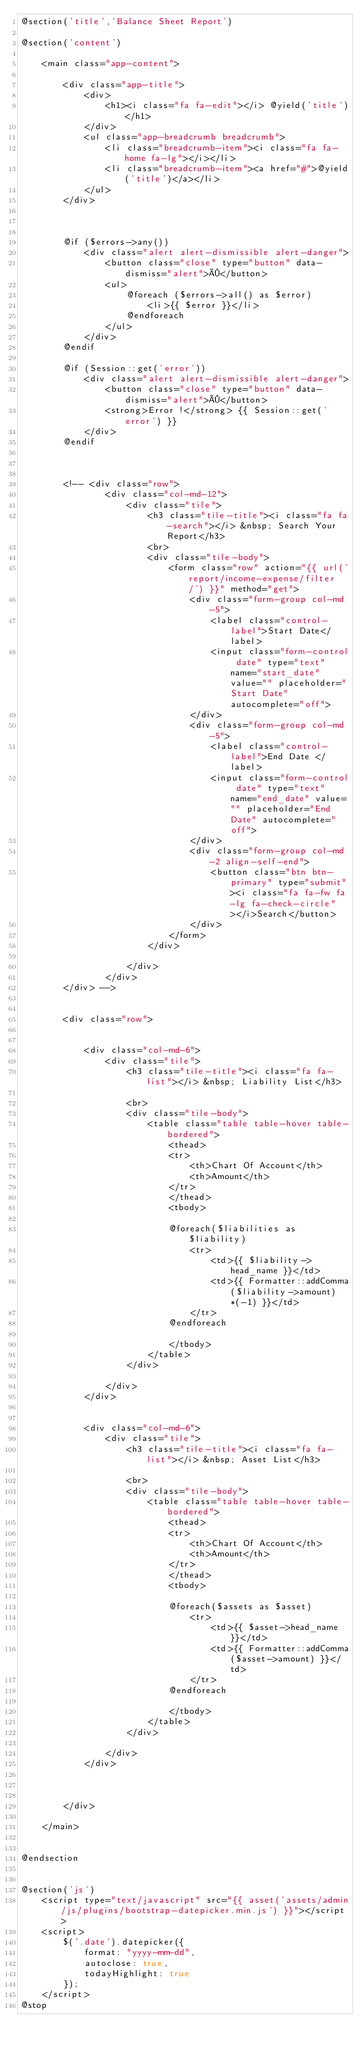Convert code to text. <code><loc_0><loc_0><loc_500><loc_500><_PHP_>@section('title','Balance Sheet Report')

@section('content')

    <main class="app-content">

        <div class="app-title">
            <div>
                <h1><i class="fa fa-edit"></i> @yield('title')</h1>
            </div>
            <ul class="app-breadcrumb breadcrumb">
                <li class="breadcrumb-item"><i class="fa fa-home fa-lg"></i></li>
                <li class="breadcrumb-item"><a href="#">@yield('title')</a></li>
            </ul>
        </div>



        @if ($errors->any())
            <div class="alert alert-dismissible alert-danger">
                <button class="close" type="button" data-dismiss="alert">×</button>
                <ul>
                    @foreach ($errors->all() as $error)
                        <li>{{ $error }}</li>
                    @endforeach
                </ul>
            </div>
        @endif

        @if (Session::get('error'))
            <div class="alert alert-dismissible alert-danger">
                <button class="close" type="button" data-dismiss="alert">×</button>
                <strong>Error !</strong> {{ Session::get('error') }}
            </div>
        @endif



        <!-- <div class="row">
                <div class="col-md-12">
                    <div class="tile">
                        <h3 class="tile-title"><i class="fa fa-search"></i> &nbsp; Search Your Report</h3>
                        <br>
                        <div class="tile-body">
                            <form class="row" action="{{ url('report/income-expense/filter/') }}" method="get">
                                <div class="form-group col-md-5">
                                    <label class="control-label">Start Date</label>
                                    <input class="form-control date" type="text" name="start_date" value="" placeholder="Start Date" autocomplete="off">
                                </div>
                                <div class="form-group col-md-5">
                                    <label class="control-label">End Date </label>
                                    <input class="form-control date" type="text" name="end_date" value="" placeholder="End Date" autocomplete="off">
                                </div>
                                <div class="form-group col-md-2 align-self-end">
                                    <button class="btn btn-primary" type="submit"><i class="fa fa-fw fa-lg fa-check-circle"></i>Search</button>
                                </div>
                            </form>
                        </div>

                    </div>
                </div>
        </div> -->


        <div class="row">


            <div class="col-md-6">
                <div class="tile">
                    <h3 class="tile-title"><i class="fa fa-list"></i> &nbsp; Liability List</h3>

                    <br>
                    <div class="tile-body">
                        <table class="table table-hover table-bordered">
                            <thead>
                            <tr>
                                <th>Chart Of Account</th>
                                <th>Amount</th>
                            </tr>
                            </thead>
                            <tbody>

                            @foreach($liabilities as $liability)
                                <tr>
                                    <td>{{ $liability->head_name }}</td>
                                    <td>{{ Formatter::addComma($liability->amount)*(-1) }}</td>
                                </tr>
                            @endforeach

                            </tbody>
                        </table>
                    </div>

                </div>
            </div>


            <div class="col-md-6">
                <div class="tile">
                    <h3 class="tile-title"><i class="fa fa-list"></i> &nbsp; Asset List</h3>

                    <br>
                    <div class="tile-body">
                        <table class="table table-hover table-bordered">
                            <thead>
                            <tr>
                                <th>Chart Of Account</th>
                                <th>Amount</th>
                            </tr>
                            </thead>
                            <tbody>

                            @foreach($assets as $asset)
                                <tr>
                                    <td>{{ $asset->head_name }}</td>
                                    <td>{{ Formatter::addComma($asset->amount) }}</td>
                                </tr>
                            @endforeach

                            </tbody>
                        </table>
                    </div>

                </div>
            </div>



        </div>

    </main>


@endsection


@section('js')
    <script type="text/javascript" src="{{ asset('assets/admin/js/plugins/bootstrap-datepicker.min.js') }}"></script>
    <script>
        $('.date').datepicker({
            format: "yyyy-mm-dd",
            autoclose: true,
            todayHighlight: true
        });
    </script>
@stop</code> 